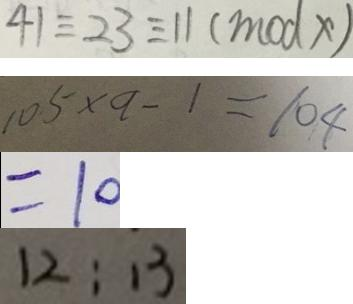Convert formula to latex. <formula><loc_0><loc_0><loc_500><loc_500>4 1 \equiv 2 3 \equiv 1 1 ( m o d x ) 
 1 0 5 \times a - 1 = 1 0 4 
 = 1 0 
 1 2 : 1 3</formula> 